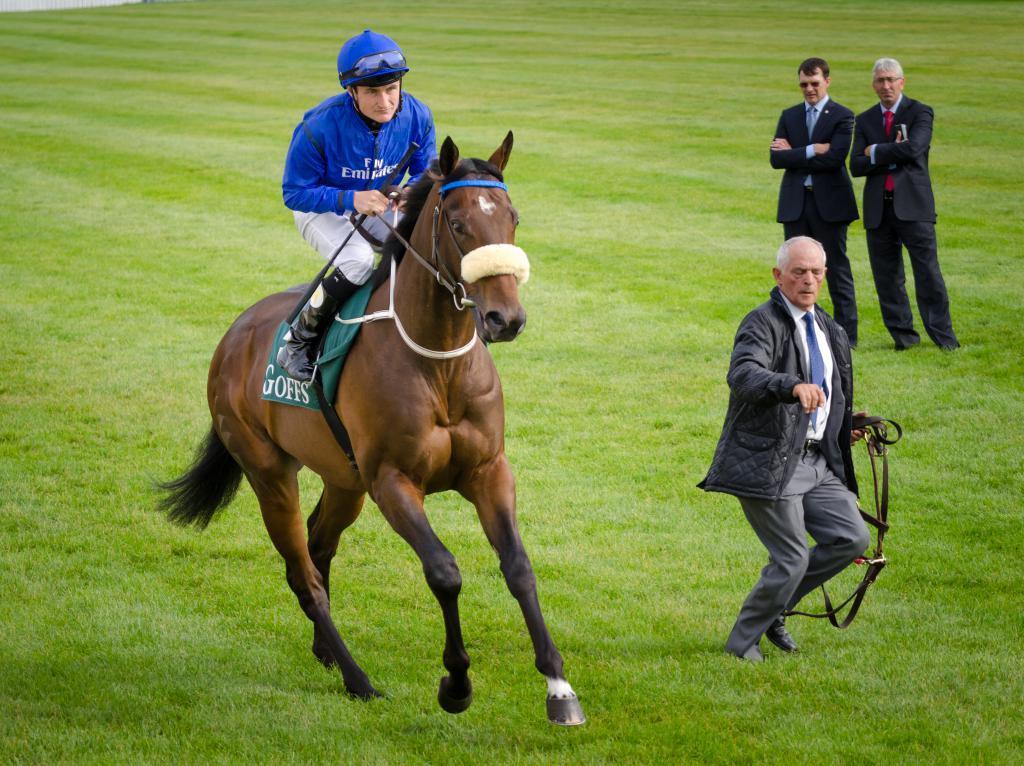Describe this image in one or two sentences. This picture describes about four people in the left side of the given image a man is riding the horse in the ground. 